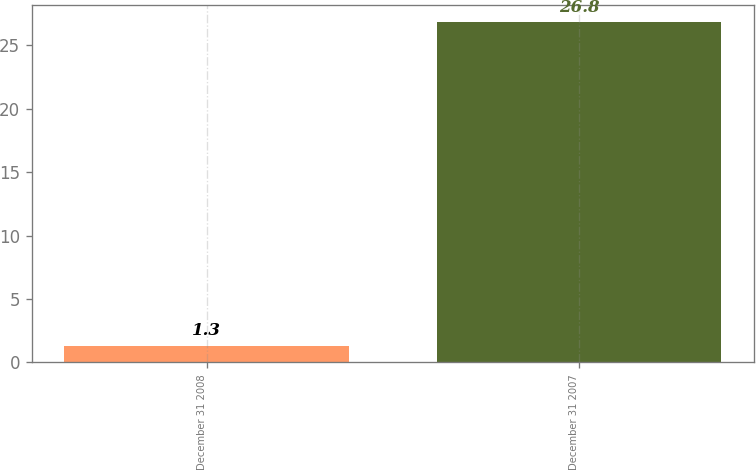Convert chart. <chart><loc_0><loc_0><loc_500><loc_500><bar_chart><fcel>December 31 2008<fcel>December 31 2007<nl><fcel>1.3<fcel>26.8<nl></chart> 